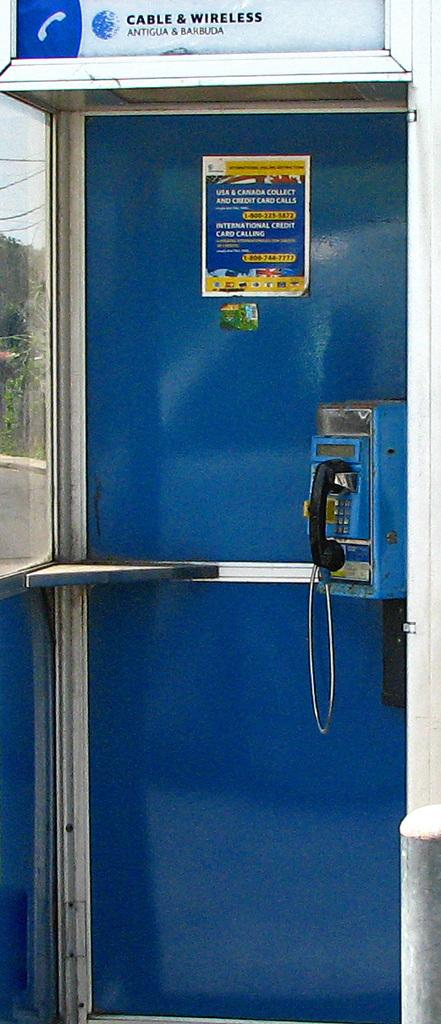What object is the main focus of the image? There is a telephone in the image. Where is the telephone situated? The telephone is located in a booth. What type of popcorn is being sold in the telephone booth? There is no popcorn present in the image; it only features a telephone in a booth. 